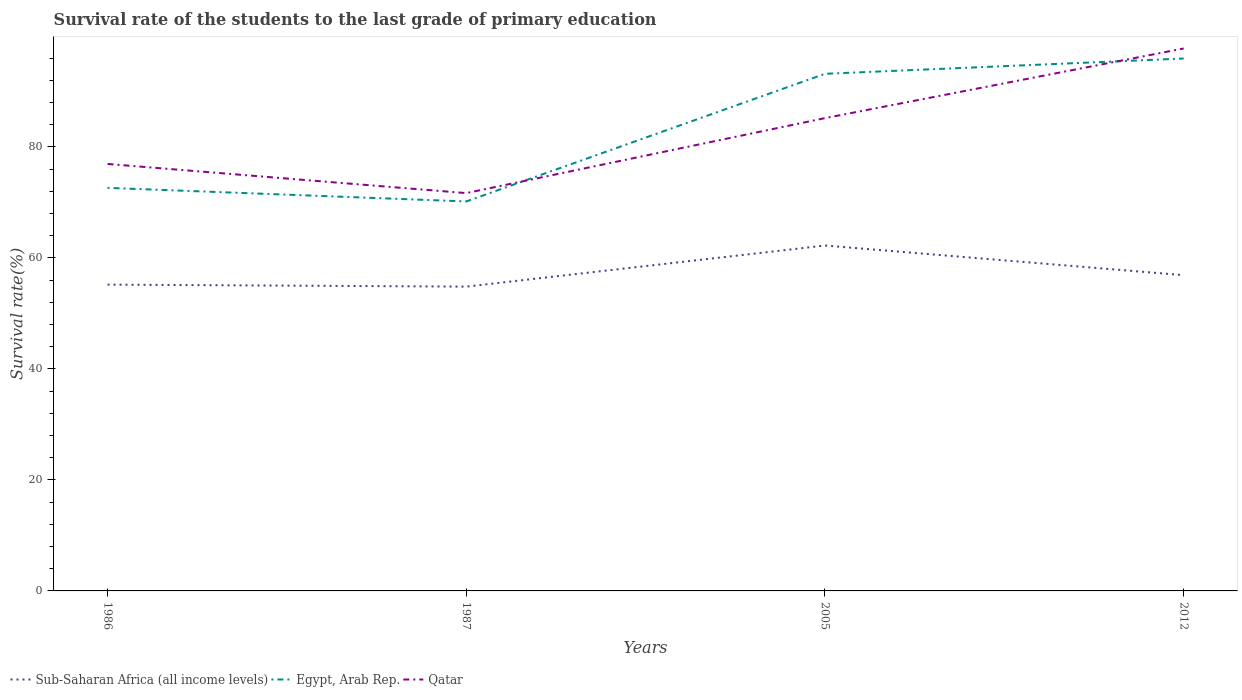How many different coloured lines are there?
Make the answer very short. 3. Across all years, what is the maximum survival rate of the students in Sub-Saharan Africa (all income levels)?
Offer a very short reply. 54.83. In which year was the survival rate of the students in Qatar maximum?
Offer a terse response. 1987. What is the total survival rate of the students in Egypt, Arab Rep. in the graph?
Your response must be concise. 2.45. What is the difference between the highest and the second highest survival rate of the students in Egypt, Arab Rep.?
Provide a short and direct response. 25.76. How many lines are there?
Ensure brevity in your answer.  3. How many years are there in the graph?
Provide a short and direct response. 4. What is the difference between two consecutive major ticks on the Y-axis?
Offer a terse response. 20. Are the values on the major ticks of Y-axis written in scientific E-notation?
Keep it short and to the point. No. Does the graph contain grids?
Give a very brief answer. No. Where does the legend appear in the graph?
Keep it short and to the point. Bottom left. How many legend labels are there?
Offer a very short reply. 3. How are the legend labels stacked?
Provide a short and direct response. Horizontal. What is the title of the graph?
Ensure brevity in your answer.  Survival rate of the students to the last grade of primary education. Does "Malta" appear as one of the legend labels in the graph?
Offer a very short reply. No. What is the label or title of the X-axis?
Your response must be concise. Years. What is the label or title of the Y-axis?
Your answer should be compact. Survival rate(%). What is the Survival rate(%) of Sub-Saharan Africa (all income levels) in 1986?
Provide a short and direct response. 55.19. What is the Survival rate(%) in Egypt, Arab Rep. in 1986?
Your response must be concise. 72.62. What is the Survival rate(%) of Qatar in 1986?
Your response must be concise. 76.93. What is the Survival rate(%) in Sub-Saharan Africa (all income levels) in 1987?
Give a very brief answer. 54.83. What is the Survival rate(%) in Egypt, Arab Rep. in 1987?
Provide a short and direct response. 70.18. What is the Survival rate(%) of Qatar in 1987?
Provide a succinct answer. 71.68. What is the Survival rate(%) in Sub-Saharan Africa (all income levels) in 2005?
Make the answer very short. 62.24. What is the Survival rate(%) of Egypt, Arab Rep. in 2005?
Make the answer very short. 93.18. What is the Survival rate(%) in Qatar in 2005?
Ensure brevity in your answer.  85.19. What is the Survival rate(%) in Sub-Saharan Africa (all income levels) in 2012?
Keep it short and to the point. 56.89. What is the Survival rate(%) in Egypt, Arab Rep. in 2012?
Ensure brevity in your answer.  95.94. What is the Survival rate(%) of Qatar in 2012?
Give a very brief answer. 97.74. Across all years, what is the maximum Survival rate(%) in Sub-Saharan Africa (all income levels)?
Provide a short and direct response. 62.24. Across all years, what is the maximum Survival rate(%) in Egypt, Arab Rep.?
Your answer should be very brief. 95.94. Across all years, what is the maximum Survival rate(%) in Qatar?
Make the answer very short. 97.74. Across all years, what is the minimum Survival rate(%) in Sub-Saharan Africa (all income levels)?
Offer a very short reply. 54.83. Across all years, what is the minimum Survival rate(%) in Egypt, Arab Rep.?
Ensure brevity in your answer.  70.18. Across all years, what is the minimum Survival rate(%) in Qatar?
Offer a very short reply. 71.68. What is the total Survival rate(%) of Sub-Saharan Africa (all income levels) in the graph?
Ensure brevity in your answer.  229.15. What is the total Survival rate(%) in Egypt, Arab Rep. in the graph?
Provide a short and direct response. 331.91. What is the total Survival rate(%) of Qatar in the graph?
Provide a short and direct response. 331.55. What is the difference between the Survival rate(%) of Sub-Saharan Africa (all income levels) in 1986 and that in 1987?
Offer a terse response. 0.36. What is the difference between the Survival rate(%) in Egypt, Arab Rep. in 1986 and that in 1987?
Provide a succinct answer. 2.45. What is the difference between the Survival rate(%) of Qatar in 1986 and that in 1987?
Provide a short and direct response. 5.25. What is the difference between the Survival rate(%) of Sub-Saharan Africa (all income levels) in 1986 and that in 2005?
Provide a short and direct response. -7.05. What is the difference between the Survival rate(%) of Egypt, Arab Rep. in 1986 and that in 2005?
Provide a short and direct response. -20.55. What is the difference between the Survival rate(%) in Qatar in 1986 and that in 2005?
Your response must be concise. -8.26. What is the difference between the Survival rate(%) in Sub-Saharan Africa (all income levels) in 1986 and that in 2012?
Your answer should be compact. -1.7. What is the difference between the Survival rate(%) of Egypt, Arab Rep. in 1986 and that in 2012?
Keep it short and to the point. -23.31. What is the difference between the Survival rate(%) of Qatar in 1986 and that in 2012?
Provide a succinct answer. -20.81. What is the difference between the Survival rate(%) in Sub-Saharan Africa (all income levels) in 1987 and that in 2005?
Provide a short and direct response. -7.41. What is the difference between the Survival rate(%) in Egypt, Arab Rep. in 1987 and that in 2005?
Make the answer very short. -23. What is the difference between the Survival rate(%) of Qatar in 1987 and that in 2005?
Give a very brief answer. -13.51. What is the difference between the Survival rate(%) in Sub-Saharan Africa (all income levels) in 1987 and that in 2012?
Make the answer very short. -2.06. What is the difference between the Survival rate(%) in Egypt, Arab Rep. in 1987 and that in 2012?
Your response must be concise. -25.76. What is the difference between the Survival rate(%) of Qatar in 1987 and that in 2012?
Make the answer very short. -26.06. What is the difference between the Survival rate(%) of Sub-Saharan Africa (all income levels) in 2005 and that in 2012?
Your answer should be very brief. 5.34. What is the difference between the Survival rate(%) of Egypt, Arab Rep. in 2005 and that in 2012?
Make the answer very short. -2.76. What is the difference between the Survival rate(%) in Qatar in 2005 and that in 2012?
Offer a terse response. -12.55. What is the difference between the Survival rate(%) of Sub-Saharan Africa (all income levels) in 1986 and the Survival rate(%) of Egypt, Arab Rep. in 1987?
Ensure brevity in your answer.  -14.99. What is the difference between the Survival rate(%) of Sub-Saharan Africa (all income levels) in 1986 and the Survival rate(%) of Qatar in 1987?
Offer a very short reply. -16.49. What is the difference between the Survival rate(%) in Egypt, Arab Rep. in 1986 and the Survival rate(%) in Qatar in 1987?
Provide a succinct answer. 0.94. What is the difference between the Survival rate(%) in Sub-Saharan Africa (all income levels) in 1986 and the Survival rate(%) in Egypt, Arab Rep. in 2005?
Your answer should be compact. -37.99. What is the difference between the Survival rate(%) of Sub-Saharan Africa (all income levels) in 1986 and the Survival rate(%) of Qatar in 2005?
Your answer should be compact. -30. What is the difference between the Survival rate(%) of Egypt, Arab Rep. in 1986 and the Survival rate(%) of Qatar in 2005?
Your answer should be very brief. -12.57. What is the difference between the Survival rate(%) of Sub-Saharan Africa (all income levels) in 1986 and the Survival rate(%) of Egypt, Arab Rep. in 2012?
Ensure brevity in your answer.  -40.75. What is the difference between the Survival rate(%) of Sub-Saharan Africa (all income levels) in 1986 and the Survival rate(%) of Qatar in 2012?
Your answer should be very brief. -42.55. What is the difference between the Survival rate(%) of Egypt, Arab Rep. in 1986 and the Survival rate(%) of Qatar in 2012?
Give a very brief answer. -25.11. What is the difference between the Survival rate(%) in Sub-Saharan Africa (all income levels) in 1987 and the Survival rate(%) in Egypt, Arab Rep. in 2005?
Offer a terse response. -38.35. What is the difference between the Survival rate(%) of Sub-Saharan Africa (all income levels) in 1987 and the Survival rate(%) of Qatar in 2005?
Offer a very short reply. -30.36. What is the difference between the Survival rate(%) of Egypt, Arab Rep. in 1987 and the Survival rate(%) of Qatar in 2005?
Provide a short and direct response. -15.02. What is the difference between the Survival rate(%) in Sub-Saharan Africa (all income levels) in 1987 and the Survival rate(%) in Egypt, Arab Rep. in 2012?
Your answer should be compact. -41.11. What is the difference between the Survival rate(%) of Sub-Saharan Africa (all income levels) in 1987 and the Survival rate(%) of Qatar in 2012?
Your answer should be compact. -42.91. What is the difference between the Survival rate(%) of Egypt, Arab Rep. in 1987 and the Survival rate(%) of Qatar in 2012?
Offer a very short reply. -27.56. What is the difference between the Survival rate(%) of Sub-Saharan Africa (all income levels) in 2005 and the Survival rate(%) of Egypt, Arab Rep. in 2012?
Offer a very short reply. -33.7. What is the difference between the Survival rate(%) in Sub-Saharan Africa (all income levels) in 2005 and the Survival rate(%) in Qatar in 2012?
Offer a very short reply. -35.5. What is the difference between the Survival rate(%) of Egypt, Arab Rep. in 2005 and the Survival rate(%) of Qatar in 2012?
Ensure brevity in your answer.  -4.56. What is the average Survival rate(%) of Sub-Saharan Africa (all income levels) per year?
Provide a succinct answer. 57.29. What is the average Survival rate(%) in Egypt, Arab Rep. per year?
Provide a succinct answer. 82.98. What is the average Survival rate(%) of Qatar per year?
Your response must be concise. 82.89. In the year 1986, what is the difference between the Survival rate(%) of Sub-Saharan Africa (all income levels) and Survival rate(%) of Egypt, Arab Rep.?
Provide a short and direct response. -17.44. In the year 1986, what is the difference between the Survival rate(%) of Sub-Saharan Africa (all income levels) and Survival rate(%) of Qatar?
Provide a succinct answer. -21.74. In the year 1986, what is the difference between the Survival rate(%) in Egypt, Arab Rep. and Survival rate(%) in Qatar?
Offer a very short reply. -4.31. In the year 1987, what is the difference between the Survival rate(%) in Sub-Saharan Africa (all income levels) and Survival rate(%) in Egypt, Arab Rep.?
Your answer should be very brief. -15.35. In the year 1987, what is the difference between the Survival rate(%) in Sub-Saharan Africa (all income levels) and Survival rate(%) in Qatar?
Offer a terse response. -16.85. In the year 1987, what is the difference between the Survival rate(%) in Egypt, Arab Rep. and Survival rate(%) in Qatar?
Your answer should be very brief. -1.51. In the year 2005, what is the difference between the Survival rate(%) of Sub-Saharan Africa (all income levels) and Survival rate(%) of Egypt, Arab Rep.?
Your response must be concise. -30.94. In the year 2005, what is the difference between the Survival rate(%) of Sub-Saharan Africa (all income levels) and Survival rate(%) of Qatar?
Your response must be concise. -22.96. In the year 2005, what is the difference between the Survival rate(%) of Egypt, Arab Rep. and Survival rate(%) of Qatar?
Make the answer very short. 7.99. In the year 2012, what is the difference between the Survival rate(%) of Sub-Saharan Africa (all income levels) and Survival rate(%) of Egypt, Arab Rep.?
Offer a very short reply. -39.04. In the year 2012, what is the difference between the Survival rate(%) of Sub-Saharan Africa (all income levels) and Survival rate(%) of Qatar?
Give a very brief answer. -40.85. In the year 2012, what is the difference between the Survival rate(%) of Egypt, Arab Rep. and Survival rate(%) of Qatar?
Your answer should be very brief. -1.8. What is the ratio of the Survival rate(%) of Sub-Saharan Africa (all income levels) in 1986 to that in 1987?
Your answer should be very brief. 1.01. What is the ratio of the Survival rate(%) of Egypt, Arab Rep. in 1986 to that in 1987?
Your response must be concise. 1.03. What is the ratio of the Survival rate(%) of Qatar in 1986 to that in 1987?
Offer a very short reply. 1.07. What is the ratio of the Survival rate(%) of Sub-Saharan Africa (all income levels) in 1986 to that in 2005?
Ensure brevity in your answer.  0.89. What is the ratio of the Survival rate(%) of Egypt, Arab Rep. in 1986 to that in 2005?
Provide a short and direct response. 0.78. What is the ratio of the Survival rate(%) in Qatar in 1986 to that in 2005?
Ensure brevity in your answer.  0.9. What is the ratio of the Survival rate(%) of Sub-Saharan Africa (all income levels) in 1986 to that in 2012?
Your answer should be very brief. 0.97. What is the ratio of the Survival rate(%) in Egypt, Arab Rep. in 1986 to that in 2012?
Offer a terse response. 0.76. What is the ratio of the Survival rate(%) in Qatar in 1986 to that in 2012?
Offer a terse response. 0.79. What is the ratio of the Survival rate(%) in Sub-Saharan Africa (all income levels) in 1987 to that in 2005?
Give a very brief answer. 0.88. What is the ratio of the Survival rate(%) of Egypt, Arab Rep. in 1987 to that in 2005?
Your response must be concise. 0.75. What is the ratio of the Survival rate(%) of Qatar in 1987 to that in 2005?
Your response must be concise. 0.84. What is the ratio of the Survival rate(%) of Sub-Saharan Africa (all income levels) in 1987 to that in 2012?
Offer a terse response. 0.96. What is the ratio of the Survival rate(%) in Egypt, Arab Rep. in 1987 to that in 2012?
Provide a short and direct response. 0.73. What is the ratio of the Survival rate(%) of Qatar in 1987 to that in 2012?
Make the answer very short. 0.73. What is the ratio of the Survival rate(%) in Sub-Saharan Africa (all income levels) in 2005 to that in 2012?
Your answer should be very brief. 1.09. What is the ratio of the Survival rate(%) in Egypt, Arab Rep. in 2005 to that in 2012?
Your answer should be very brief. 0.97. What is the ratio of the Survival rate(%) in Qatar in 2005 to that in 2012?
Provide a short and direct response. 0.87. What is the difference between the highest and the second highest Survival rate(%) in Sub-Saharan Africa (all income levels)?
Keep it short and to the point. 5.34. What is the difference between the highest and the second highest Survival rate(%) in Egypt, Arab Rep.?
Your answer should be very brief. 2.76. What is the difference between the highest and the second highest Survival rate(%) of Qatar?
Offer a very short reply. 12.55. What is the difference between the highest and the lowest Survival rate(%) in Sub-Saharan Africa (all income levels)?
Ensure brevity in your answer.  7.41. What is the difference between the highest and the lowest Survival rate(%) in Egypt, Arab Rep.?
Your answer should be very brief. 25.76. What is the difference between the highest and the lowest Survival rate(%) in Qatar?
Offer a very short reply. 26.06. 